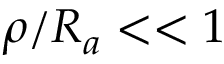Convert formula to latex. <formula><loc_0><loc_0><loc_500><loc_500>\rho / R _ { a } < < 1</formula> 